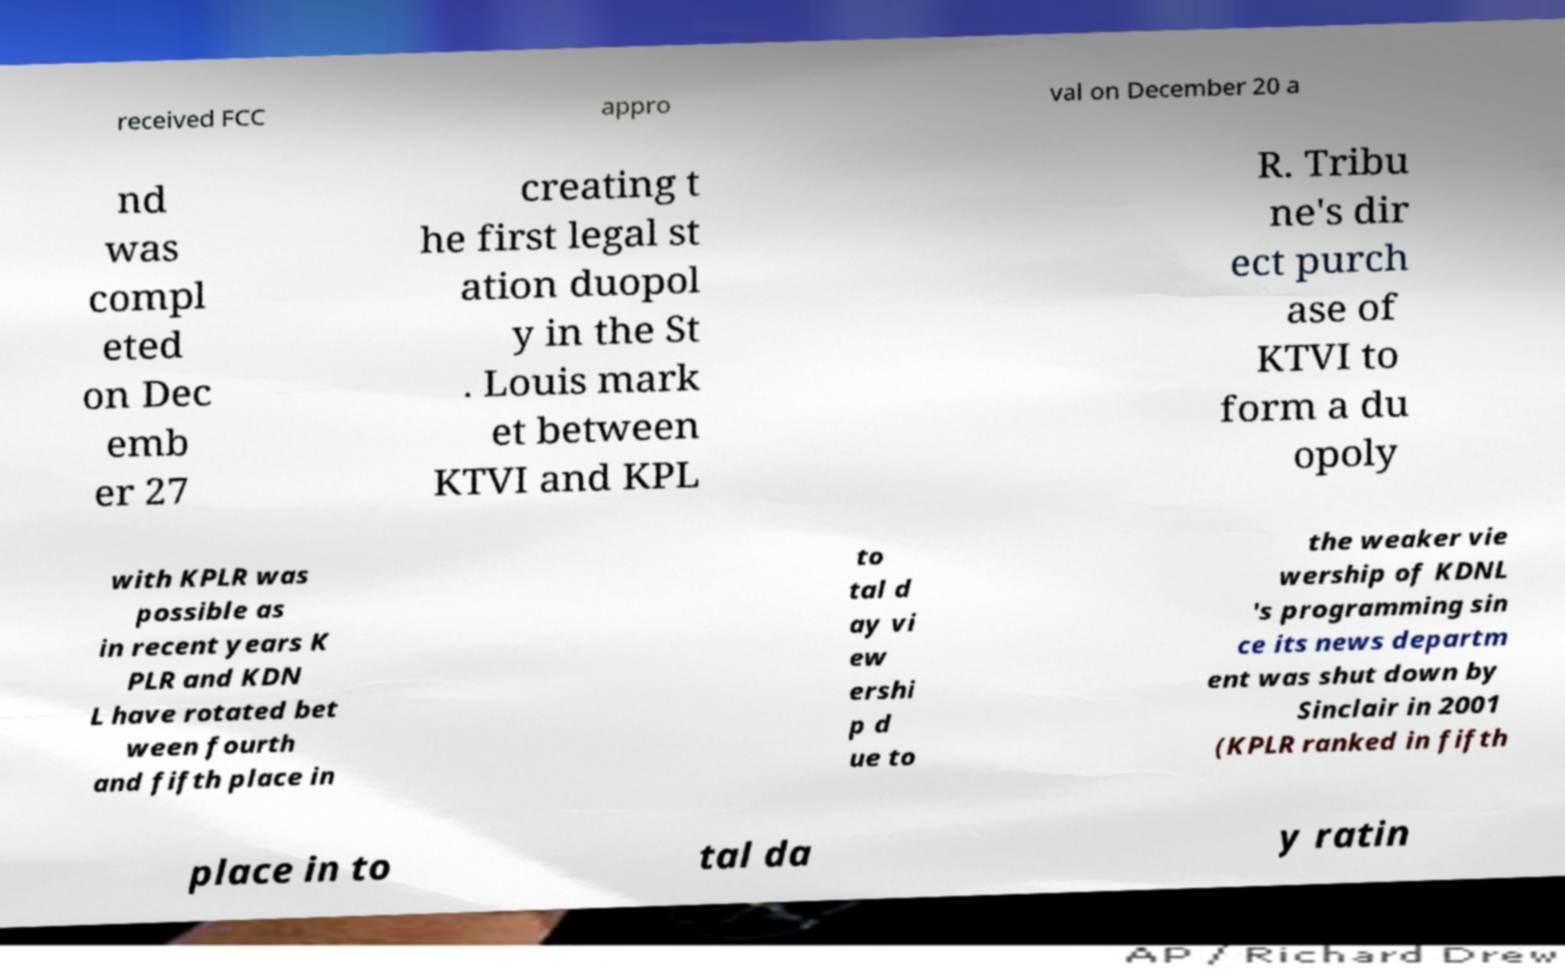For documentation purposes, I need the text within this image transcribed. Could you provide that? received FCC appro val on December 20 a nd was compl eted on Dec emb er 27 creating t he first legal st ation duopol y in the St . Louis mark et between KTVI and KPL R. Tribu ne's dir ect purch ase of KTVI to form a du opoly with KPLR was possible as in recent years K PLR and KDN L have rotated bet ween fourth and fifth place in to tal d ay vi ew ershi p d ue to the weaker vie wership of KDNL 's programming sin ce its news departm ent was shut down by Sinclair in 2001 (KPLR ranked in fifth place in to tal da y ratin 